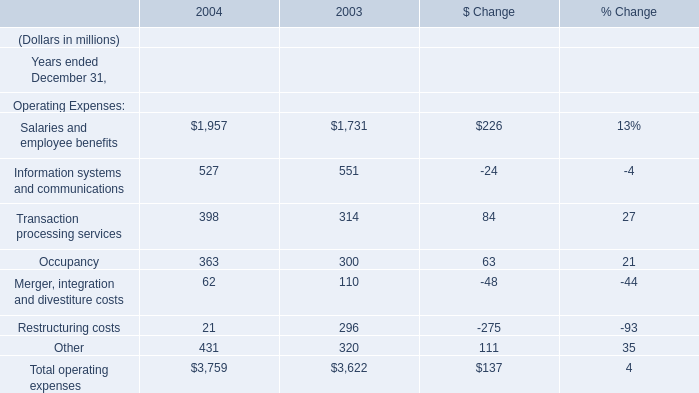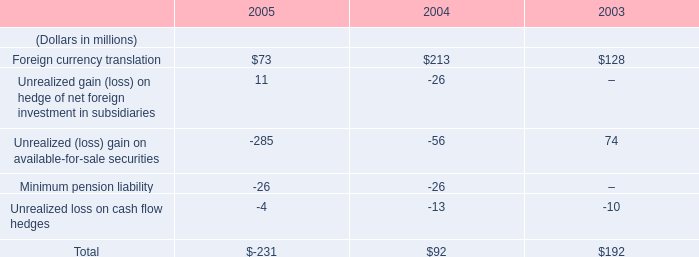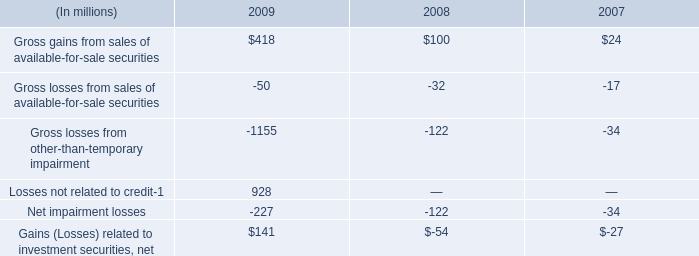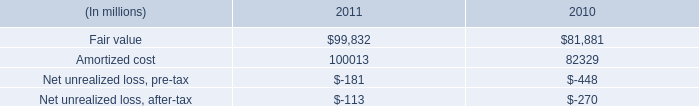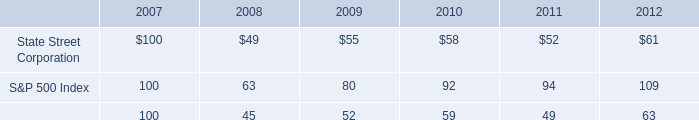What's the total value of all Operating Expenses that are smaller than 100 in 2004? (in million) 
Computations: (62 + 21)
Answer: 83.0. 